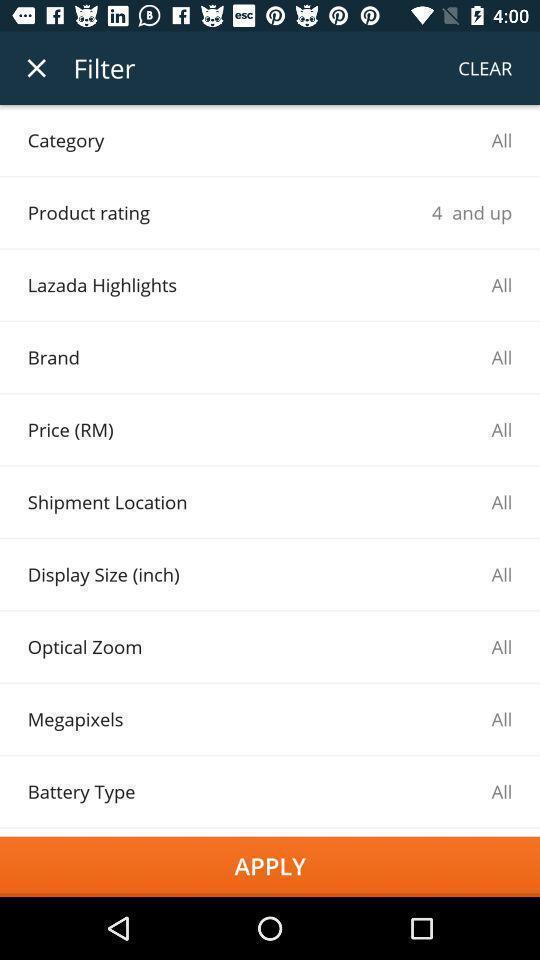Provide a textual representation of this image. Page showing category options in a shopping related app. 